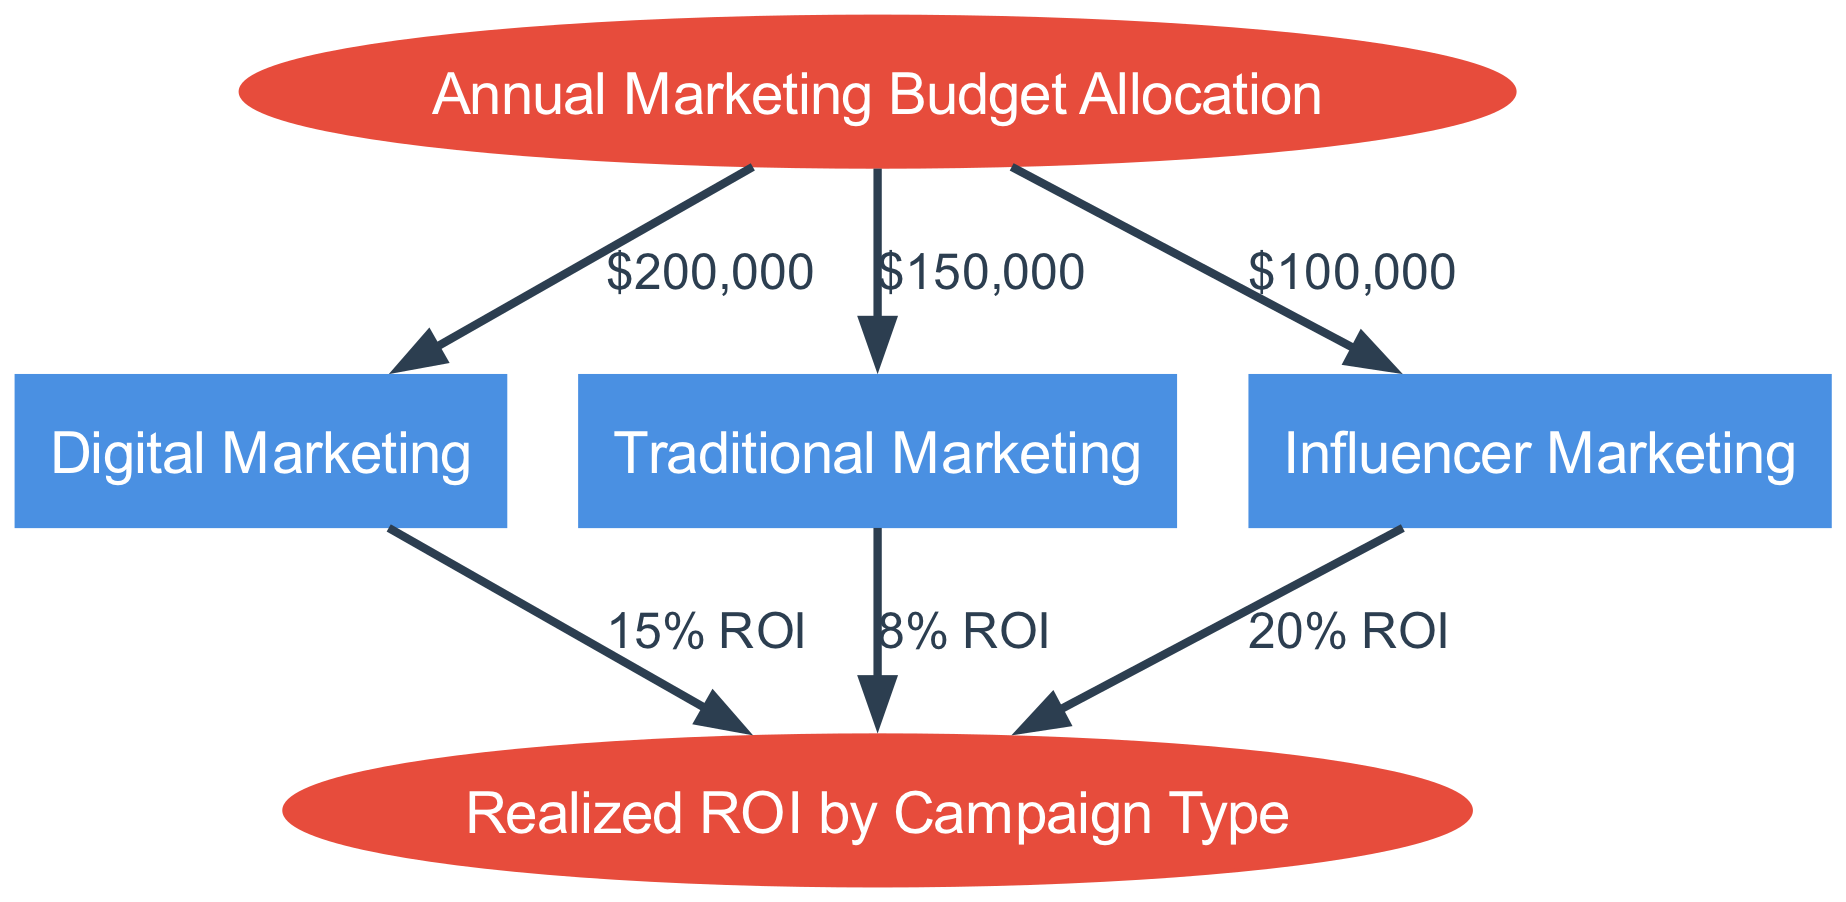What is the budget allocated to digital marketing? The edge connecting "Annual Marketing Budget Allocation" to "Digital Marketing" shows a label of "$200,000", which indicates the amount allocated for this campaign type.
Answer: $200,000 What is the realized ROI for traditional marketing? The edge connecting "Traditional Marketing" to "Realized ROI by Campaign Type" indicates an ROI of "8%". This is the percentage gain realized from the investment in traditional marketing.
Answer: 8% How many campaign types are represented in the diagram? The nodes representing campaign types are "Digital Marketing", "Traditional Marketing", and "Influencer Marketing", totaling three campaign types.
Answer: 3 Which campaign type has the highest ROI? By comparing the ROIs of the campaign types, "Influencer Marketing" shows an ROI of "20%", which is higher than the others: "15%" for digital and "8%" for traditional.
Answer: Influencer Marketing What is the total marketing budget allocated across all campaign types? Adding the allocations for each campaign type: $200,000 (digital) + $150,000 (traditional) + $100,000 (influencer) results in a total budget of $450,000.
Answer: $450,000 How is the relationship between budget allocation and realized ROI depicted in the diagram? The diagram illustrates that the annual marketing budget allocation leads into various campaign types, and each type has a corresponding realized ROI shown as edges leading to "Realized ROI by Campaign Type". This represents how allocation impacts returns.
Answer: Through directed edges What percentage of the total budget is allocated to influencer marketing? The budget for influencer marketing is $100,000 out of a total of $450,000 (calculated previously). To find the percentage: (100,000/450,000) * 100, which equals about 22.22%.
Answer: 22.22% Which campaign type received the lowest budget allocation? "Traditional Marketing" has a budget allocation of "$150,000", which is lower than "Digital Marketing" at "$200,000" and higher than "Influencer Marketing" at "$100,000", making it the lowest.
Answer: Influencer Marketing 